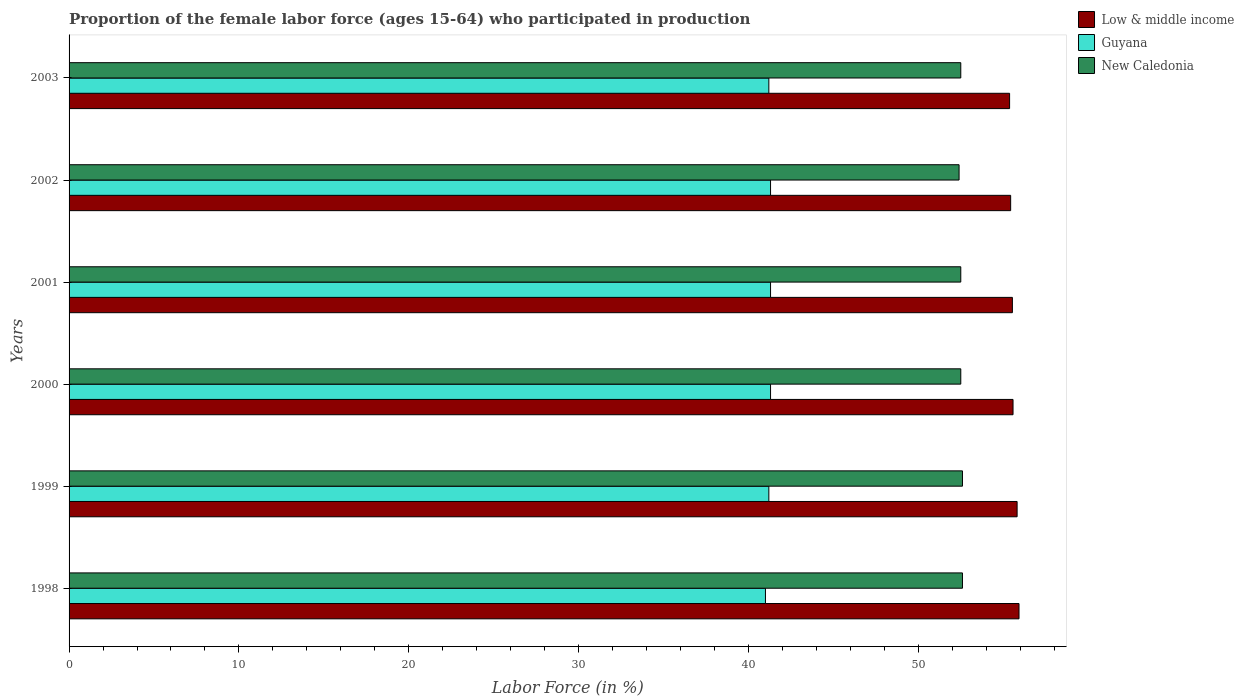Are the number of bars on each tick of the Y-axis equal?
Offer a terse response. Yes. How many bars are there on the 1st tick from the bottom?
Offer a terse response. 3. What is the proportion of the female labor force who participated in production in New Caledonia in 2001?
Make the answer very short. 52.5. Across all years, what is the maximum proportion of the female labor force who participated in production in Low & middle income?
Ensure brevity in your answer.  55.93. In which year was the proportion of the female labor force who participated in production in New Caledonia maximum?
Your answer should be very brief. 1998. What is the total proportion of the female labor force who participated in production in Low & middle income in the graph?
Offer a very short reply. 333.67. What is the difference between the proportion of the female labor force who participated in production in New Caledonia in 1999 and that in 2003?
Make the answer very short. 0.1. What is the difference between the proportion of the female labor force who participated in production in Low & middle income in 2003 and the proportion of the female labor force who participated in production in Guyana in 2002?
Give a very brief answer. 14.07. What is the average proportion of the female labor force who participated in production in New Caledonia per year?
Your answer should be compact. 52.52. In the year 2000, what is the difference between the proportion of the female labor force who participated in production in Guyana and proportion of the female labor force who participated in production in Low & middle income?
Your answer should be very brief. -14.28. What is the ratio of the proportion of the female labor force who participated in production in Guyana in 1999 to that in 2002?
Offer a terse response. 1. Is the difference between the proportion of the female labor force who participated in production in Guyana in 2000 and 2002 greater than the difference between the proportion of the female labor force who participated in production in Low & middle income in 2000 and 2002?
Your answer should be very brief. No. What is the difference between the highest and the second highest proportion of the female labor force who participated in production in Low & middle income?
Provide a succinct answer. 0.11. What is the difference between the highest and the lowest proportion of the female labor force who participated in production in Low & middle income?
Your response must be concise. 0.55. In how many years, is the proportion of the female labor force who participated in production in Guyana greater than the average proportion of the female labor force who participated in production in Guyana taken over all years?
Your response must be concise. 3. What does the 1st bar from the top in 1999 represents?
Your response must be concise. New Caledonia. What does the 2nd bar from the bottom in 2003 represents?
Provide a succinct answer. Guyana. How many bars are there?
Provide a short and direct response. 18. How many years are there in the graph?
Your answer should be very brief. 6. What is the difference between two consecutive major ticks on the X-axis?
Give a very brief answer. 10. Are the values on the major ticks of X-axis written in scientific E-notation?
Offer a very short reply. No. Does the graph contain grids?
Offer a very short reply. No. Where does the legend appear in the graph?
Make the answer very short. Top right. What is the title of the graph?
Offer a terse response. Proportion of the female labor force (ages 15-64) who participated in production. What is the label or title of the X-axis?
Keep it short and to the point. Labor Force (in %). What is the Labor Force (in %) of Low & middle income in 1998?
Provide a succinct answer. 55.93. What is the Labor Force (in %) in New Caledonia in 1998?
Make the answer very short. 52.6. What is the Labor Force (in %) of Low & middle income in 1999?
Your response must be concise. 55.82. What is the Labor Force (in %) in Guyana in 1999?
Your answer should be very brief. 41.2. What is the Labor Force (in %) of New Caledonia in 1999?
Provide a succinct answer. 52.6. What is the Labor Force (in %) of Low & middle income in 2000?
Provide a short and direct response. 55.58. What is the Labor Force (in %) of Guyana in 2000?
Your answer should be compact. 41.3. What is the Labor Force (in %) in New Caledonia in 2000?
Your answer should be very brief. 52.5. What is the Labor Force (in %) in Low & middle income in 2001?
Provide a short and direct response. 55.54. What is the Labor Force (in %) of Guyana in 2001?
Give a very brief answer. 41.3. What is the Labor Force (in %) in New Caledonia in 2001?
Provide a succinct answer. 52.5. What is the Labor Force (in %) of Low & middle income in 2002?
Keep it short and to the point. 55.44. What is the Labor Force (in %) in Guyana in 2002?
Give a very brief answer. 41.3. What is the Labor Force (in %) in New Caledonia in 2002?
Offer a terse response. 52.4. What is the Labor Force (in %) of Low & middle income in 2003?
Offer a very short reply. 55.37. What is the Labor Force (in %) in Guyana in 2003?
Ensure brevity in your answer.  41.2. What is the Labor Force (in %) of New Caledonia in 2003?
Offer a terse response. 52.5. Across all years, what is the maximum Labor Force (in %) in Low & middle income?
Give a very brief answer. 55.93. Across all years, what is the maximum Labor Force (in %) of Guyana?
Your response must be concise. 41.3. Across all years, what is the maximum Labor Force (in %) of New Caledonia?
Ensure brevity in your answer.  52.6. Across all years, what is the minimum Labor Force (in %) in Low & middle income?
Provide a succinct answer. 55.37. Across all years, what is the minimum Labor Force (in %) of New Caledonia?
Keep it short and to the point. 52.4. What is the total Labor Force (in %) of Low & middle income in the graph?
Make the answer very short. 333.67. What is the total Labor Force (in %) of Guyana in the graph?
Provide a short and direct response. 247.3. What is the total Labor Force (in %) of New Caledonia in the graph?
Give a very brief answer. 315.1. What is the difference between the Labor Force (in %) of Low & middle income in 1998 and that in 1999?
Provide a succinct answer. 0.11. What is the difference between the Labor Force (in %) in Guyana in 1998 and that in 1999?
Your response must be concise. -0.2. What is the difference between the Labor Force (in %) in New Caledonia in 1998 and that in 1999?
Your response must be concise. 0. What is the difference between the Labor Force (in %) in Low & middle income in 1998 and that in 2000?
Your response must be concise. 0.35. What is the difference between the Labor Force (in %) of Guyana in 1998 and that in 2000?
Provide a short and direct response. -0.3. What is the difference between the Labor Force (in %) in New Caledonia in 1998 and that in 2000?
Offer a very short reply. 0.1. What is the difference between the Labor Force (in %) of Low & middle income in 1998 and that in 2001?
Your response must be concise. 0.39. What is the difference between the Labor Force (in %) in New Caledonia in 1998 and that in 2001?
Offer a very short reply. 0.1. What is the difference between the Labor Force (in %) of Low & middle income in 1998 and that in 2002?
Keep it short and to the point. 0.49. What is the difference between the Labor Force (in %) of New Caledonia in 1998 and that in 2002?
Offer a terse response. 0.2. What is the difference between the Labor Force (in %) in Low & middle income in 1998 and that in 2003?
Offer a very short reply. 0.55. What is the difference between the Labor Force (in %) of New Caledonia in 1998 and that in 2003?
Your answer should be compact. 0.1. What is the difference between the Labor Force (in %) in Low & middle income in 1999 and that in 2000?
Provide a short and direct response. 0.24. What is the difference between the Labor Force (in %) in Guyana in 1999 and that in 2000?
Ensure brevity in your answer.  -0.1. What is the difference between the Labor Force (in %) in New Caledonia in 1999 and that in 2000?
Your answer should be compact. 0.1. What is the difference between the Labor Force (in %) of Low & middle income in 1999 and that in 2001?
Your answer should be compact. 0.28. What is the difference between the Labor Force (in %) in Guyana in 1999 and that in 2001?
Provide a succinct answer. -0.1. What is the difference between the Labor Force (in %) in Low & middle income in 1999 and that in 2002?
Your response must be concise. 0.38. What is the difference between the Labor Force (in %) in New Caledonia in 1999 and that in 2002?
Your answer should be compact. 0.2. What is the difference between the Labor Force (in %) in Low & middle income in 1999 and that in 2003?
Your answer should be very brief. 0.44. What is the difference between the Labor Force (in %) in Guyana in 1999 and that in 2003?
Offer a very short reply. 0. What is the difference between the Labor Force (in %) of Low & middle income in 2000 and that in 2001?
Provide a succinct answer. 0.04. What is the difference between the Labor Force (in %) in Low & middle income in 2000 and that in 2002?
Your answer should be very brief. 0.14. What is the difference between the Labor Force (in %) in Guyana in 2000 and that in 2002?
Provide a succinct answer. 0. What is the difference between the Labor Force (in %) in New Caledonia in 2000 and that in 2002?
Provide a succinct answer. 0.1. What is the difference between the Labor Force (in %) in Low & middle income in 2000 and that in 2003?
Make the answer very short. 0.2. What is the difference between the Labor Force (in %) in New Caledonia in 2000 and that in 2003?
Provide a succinct answer. 0. What is the difference between the Labor Force (in %) of Low & middle income in 2001 and that in 2002?
Give a very brief answer. 0.1. What is the difference between the Labor Force (in %) in Guyana in 2001 and that in 2002?
Your response must be concise. 0. What is the difference between the Labor Force (in %) in New Caledonia in 2001 and that in 2002?
Offer a very short reply. 0.1. What is the difference between the Labor Force (in %) of Low & middle income in 2001 and that in 2003?
Give a very brief answer. 0.16. What is the difference between the Labor Force (in %) of Low & middle income in 2002 and that in 2003?
Offer a very short reply. 0.06. What is the difference between the Labor Force (in %) in Guyana in 2002 and that in 2003?
Provide a succinct answer. 0.1. What is the difference between the Labor Force (in %) in New Caledonia in 2002 and that in 2003?
Ensure brevity in your answer.  -0.1. What is the difference between the Labor Force (in %) in Low & middle income in 1998 and the Labor Force (in %) in Guyana in 1999?
Provide a succinct answer. 14.73. What is the difference between the Labor Force (in %) of Low & middle income in 1998 and the Labor Force (in %) of New Caledonia in 1999?
Your answer should be very brief. 3.33. What is the difference between the Labor Force (in %) of Low & middle income in 1998 and the Labor Force (in %) of Guyana in 2000?
Provide a succinct answer. 14.63. What is the difference between the Labor Force (in %) of Low & middle income in 1998 and the Labor Force (in %) of New Caledonia in 2000?
Provide a short and direct response. 3.43. What is the difference between the Labor Force (in %) of Guyana in 1998 and the Labor Force (in %) of New Caledonia in 2000?
Your answer should be compact. -11.5. What is the difference between the Labor Force (in %) of Low & middle income in 1998 and the Labor Force (in %) of Guyana in 2001?
Provide a succinct answer. 14.63. What is the difference between the Labor Force (in %) of Low & middle income in 1998 and the Labor Force (in %) of New Caledonia in 2001?
Ensure brevity in your answer.  3.43. What is the difference between the Labor Force (in %) in Guyana in 1998 and the Labor Force (in %) in New Caledonia in 2001?
Offer a very short reply. -11.5. What is the difference between the Labor Force (in %) in Low & middle income in 1998 and the Labor Force (in %) in Guyana in 2002?
Keep it short and to the point. 14.63. What is the difference between the Labor Force (in %) in Low & middle income in 1998 and the Labor Force (in %) in New Caledonia in 2002?
Provide a succinct answer. 3.53. What is the difference between the Labor Force (in %) of Low & middle income in 1998 and the Labor Force (in %) of Guyana in 2003?
Offer a very short reply. 14.73. What is the difference between the Labor Force (in %) of Low & middle income in 1998 and the Labor Force (in %) of New Caledonia in 2003?
Provide a short and direct response. 3.43. What is the difference between the Labor Force (in %) in Guyana in 1998 and the Labor Force (in %) in New Caledonia in 2003?
Offer a very short reply. -11.5. What is the difference between the Labor Force (in %) in Low & middle income in 1999 and the Labor Force (in %) in Guyana in 2000?
Make the answer very short. 14.52. What is the difference between the Labor Force (in %) in Low & middle income in 1999 and the Labor Force (in %) in New Caledonia in 2000?
Your answer should be very brief. 3.32. What is the difference between the Labor Force (in %) in Guyana in 1999 and the Labor Force (in %) in New Caledonia in 2000?
Your response must be concise. -11.3. What is the difference between the Labor Force (in %) in Low & middle income in 1999 and the Labor Force (in %) in Guyana in 2001?
Make the answer very short. 14.52. What is the difference between the Labor Force (in %) of Low & middle income in 1999 and the Labor Force (in %) of New Caledonia in 2001?
Offer a very short reply. 3.32. What is the difference between the Labor Force (in %) in Guyana in 1999 and the Labor Force (in %) in New Caledonia in 2001?
Give a very brief answer. -11.3. What is the difference between the Labor Force (in %) of Low & middle income in 1999 and the Labor Force (in %) of Guyana in 2002?
Keep it short and to the point. 14.52. What is the difference between the Labor Force (in %) in Low & middle income in 1999 and the Labor Force (in %) in New Caledonia in 2002?
Your response must be concise. 3.42. What is the difference between the Labor Force (in %) of Low & middle income in 1999 and the Labor Force (in %) of Guyana in 2003?
Offer a very short reply. 14.62. What is the difference between the Labor Force (in %) in Low & middle income in 1999 and the Labor Force (in %) in New Caledonia in 2003?
Offer a very short reply. 3.32. What is the difference between the Labor Force (in %) in Low & middle income in 2000 and the Labor Force (in %) in Guyana in 2001?
Provide a short and direct response. 14.28. What is the difference between the Labor Force (in %) of Low & middle income in 2000 and the Labor Force (in %) of New Caledonia in 2001?
Your answer should be very brief. 3.08. What is the difference between the Labor Force (in %) in Guyana in 2000 and the Labor Force (in %) in New Caledonia in 2001?
Keep it short and to the point. -11.2. What is the difference between the Labor Force (in %) in Low & middle income in 2000 and the Labor Force (in %) in Guyana in 2002?
Provide a succinct answer. 14.28. What is the difference between the Labor Force (in %) in Low & middle income in 2000 and the Labor Force (in %) in New Caledonia in 2002?
Your response must be concise. 3.18. What is the difference between the Labor Force (in %) of Low & middle income in 2000 and the Labor Force (in %) of Guyana in 2003?
Provide a short and direct response. 14.38. What is the difference between the Labor Force (in %) in Low & middle income in 2000 and the Labor Force (in %) in New Caledonia in 2003?
Your answer should be very brief. 3.08. What is the difference between the Labor Force (in %) of Low & middle income in 2001 and the Labor Force (in %) of Guyana in 2002?
Offer a terse response. 14.24. What is the difference between the Labor Force (in %) in Low & middle income in 2001 and the Labor Force (in %) in New Caledonia in 2002?
Keep it short and to the point. 3.14. What is the difference between the Labor Force (in %) in Guyana in 2001 and the Labor Force (in %) in New Caledonia in 2002?
Offer a very short reply. -11.1. What is the difference between the Labor Force (in %) in Low & middle income in 2001 and the Labor Force (in %) in Guyana in 2003?
Make the answer very short. 14.34. What is the difference between the Labor Force (in %) of Low & middle income in 2001 and the Labor Force (in %) of New Caledonia in 2003?
Offer a terse response. 3.04. What is the difference between the Labor Force (in %) of Guyana in 2001 and the Labor Force (in %) of New Caledonia in 2003?
Keep it short and to the point. -11.2. What is the difference between the Labor Force (in %) in Low & middle income in 2002 and the Labor Force (in %) in Guyana in 2003?
Offer a very short reply. 14.24. What is the difference between the Labor Force (in %) of Low & middle income in 2002 and the Labor Force (in %) of New Caledonia in 2003?
Your response must be concise. 2.94. What is the average Labor Force (in %) in Low & middle income per year?
Provide a succinct answer. 55.61. What is the average Labor Force (in %) in Guyana per year?
Make the answer very short. 41.22. What is the average Labor Force (in %) of New Caledonia per year?
Give a very brief answer. 52.52. In the year 1998, what is the difference between the Labor Force (in %) in Low & middle income and Labor Force (in %) in Guyana?
Offer a very short reply. 14.93. In the year 1998, what is the difference between the Labor Force (in %) in Low & middle income and Labor Force (in %) in New Caledonia?
Offer a terse response. 3.33. In the year 1998, what is the difference between the Labor Force (in %) of Guyana and Labor Force (in %) of New Caledonia?
Provide a succinct answer. -11.6. In the year 1999, what is the difference between the Labor Force (in %) of Low & middle income and Labor Force (in %) of Guyana?
Offer a very short reply. 14.62. In the year 1999, what is the difference between the Labor Force (in %) in Low & middle income and Labor Force (in %) in New Caledonia?
Your answer should be very brief. 3.22. In the year 2000, what is the difference between the Labor Force (in %) of Low & middle income and Labor Force (in %) of Guyana?
Provide a short and direct response. 14.28. In the year 2000, what is the difference between the Labor Force (in %) of Low & middle income and Labor Force (in %) of New Caledonia?
Offer a very short reply. 3.08. In the year 2000, what is the difference between the Labor Force (in %) of Guyana and Labor Force (in %) of New Caledonia?
Provide a short and direct response. -11.2. In the year 2001, what is the difference between the Labor Force (in %) of Low & middle income and Labor Force (in %) of Guyana?
Offer a very short reply. 14.24. In the year 2001, what is the difference between the Labor Force (in %) of Low & middle income and Labor Force (in %) of New Caledonia?
Provide a succinct answer. 3.04. In the year 2002, what is the difference between the Labor Force (in %) in Low & middle income and Labor Force (in %) in Guyana?
Your response must be concise. 14.14. In the year 2002, what is the difference between the Labor Force (in %) in Low & middle income and Labor Force (in %) in New Caledonia?
Provide a short and direct response. 3.04. In the year 2002, what is the difference between the Labor Force (in %) of Guyana and Labor Force (in %) of New Caledonia?
Offer a terse response. -11.1. In the year 2003, what is the difference between the Labor Force (in %) of Low & middle income and Labor Force (in %) of Guyana?
Keep it short and to the point. 14.17. In the year 2003, what is the difference between the Labor Force (in %) in Low & middle income and Labor Force (in %) in New Caledonia?
Give a very brief answer. 2.87. In the year 2003, what is the difference between the Labor Force (in %) in Guyana and Labor Force (in %) in New Caledonia?
Provide a short and direct response. -11.3. What is the ratio of the Labor Force (in %) in Low & middle income in 1998 to that in 1999?
Offer a terse response. 1. What is the ratio of the Labor Force (in %) of Guyana in 1998 to that in 1999?
Provide a short and direct response. 1. What is the ratio of the Labor Force (in %) of New Caledonia in 1998 to that in 1999?
Your answer should be very brief. 1. What is the ratio of the Labor Force (in %) in New Caledonia in 1998 to that in 2000?
Your answer should be very brief. 1. What is the ratio of the Labor Force (in %) of Low & middle income in 1998 to that in 2001?
Give a very brief answer. 1.01. What is the ratio of the Labor Force (in %) in New Caledonia in 1998 to that in 2001?
Offer a terse response. 1. What is the ratio of the Labor Force (in %) in Low & middle income in 1998 to that in 2002?
Your answer should be compact. 1.01. What is the ratio of the Labor Force (in %) of Guyana in 1998 to that in 2002?
Provide a short and direct response. 0.99. What is the ratio of the Labor Force (in %) of New Caledonia in 1998 to that in 2002?
Provide a succinct answer. 1. What is the ratio of the Labor Force (in %) of Low & middle income in 1998 to that in 2003?
Keep it short and to the point. 1.01. What is the ratio of the Labor Force (in %) of New Caledonia in 1998 to that in 2003?
Keep it short and to the point. 1. What is the ratio of the Labor Force (in %) of New Caledonia in 1999 to that in 2000?
Provide a short and direct response. 1. What is the ratio of the Labor Force (in %) of Low & middle income in 1999 to that in 2001?
Provide a short and direct response. 1. What is the ratio of the Labor Force (in %) of Guyana in 1999 to that in 2001?
Offer a very short reply. 1. What is the ratio of the Labor Force (in %) in New Caledonia in 1999 to that in 2002?
Offer a terse response. 1. What is the ratio of the Labor Force (in %) in Guyana in 1999 to that in 2003?
Provide a short and direct response. 1. What is the ratio of the Labor Force (in %) in Low & middle income in 2000 to that in 2002?
Your answer should be compact. 1. What is the ratio of the Labor Force (in %) of Guyana in 2000 to that in 2003?
Ensure brevity in your answer.  1. What is the ratio of the Labor Force (in %) of New Caledonia in 2000 to that in 2003?
Provide a short and direct response. 1. What is the ratio of the Labor Force (in %) of Guyana in 2001 to that in 2002?
Ensure brevity in your answer.  1. What is the ratio of the Labor Force (in %) of New Caledonia in 2001 to that in 2002?
Offer a very short reply. 1. What is the ratio of the Labor Force (in %) of Guyana in 2001 to that in 2003?
Offer a very short reply. 1. What is the ratio of the Labor Force (in %) in New Caledonia in 2001 to that in 2003?
Your answer should be very brief. 1. What is the ratio of the Labor Force (in %) in New Caledonia in 2002 to that in 2003?
Make the answer very short. 1. What is the difference between the highest and the second highest Labor Force (in %) in Low & middle income?
Your answer should be compact. 0.11. What is the difference between the highest and the second highest Labor Force (in %) of New Caledonia?
Your response must be concise. 0. What is the difference between the highest and the lowest Labor Force (in %) in Low & middle income?
Keep it short and to the point. 0.55. What is the difference between the highest and the lowest Labor Force (in %) of New Caledonia?
Offer a terse response. 0.2. 